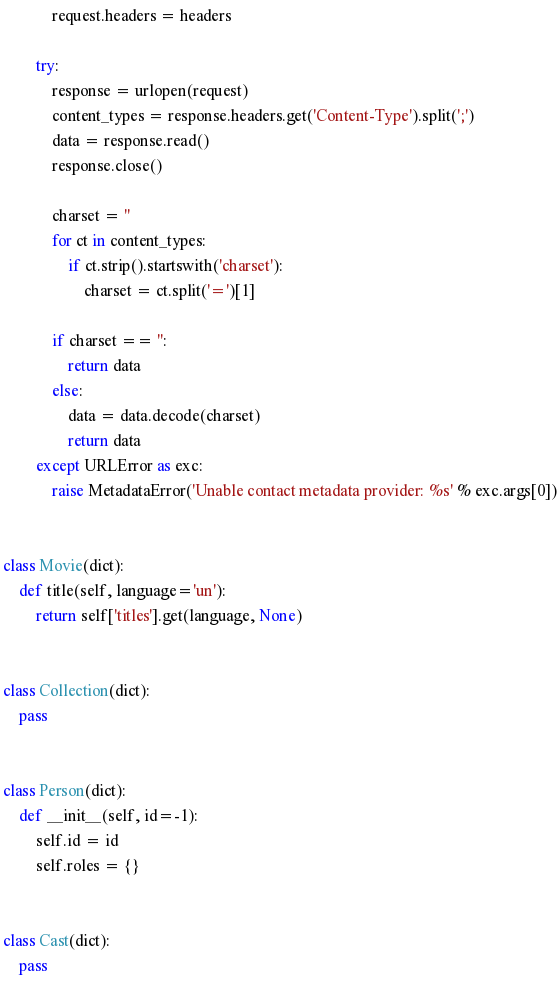Convert code to text. <code><loc_0><loc_0><loc_500><loc_500><_Python_>            request.headers = headers
        
        try:
            response = urlopen(request)
            content_types = response.headers.get('Content-Type').split(';')
            data = response.read()
            response.close()
            
            charset = ''
            for ct in content_types:
                if ct.strip().startswith('charset'):
                    charset = ct.split('=')[1]
                    
            if charset == '':
                return data
            else:
                data = data.decode(charset)
                return data
        except URLError as exc:
            raise MetadataError('Unable contact metadata provider: %s' % exc.args[0])


class Movie(dict):
    def title(self, language='un'):
        return self['titles'].get(language, None)


class Collection(dict):
    pass


class Person(dict):
    def __init__(self, id=-1):
        self.id = id
        self.roles = {}


class Cast(dict):
    pass


</code> 